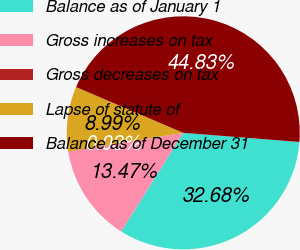<chart> <loc_0><loc_0><loc_500><loc_500><pie_chart><fcel>Balance as of January 1<fcel>Gross increases on tax<fcel>Gross decreases on tax<fcel>Lapse of statute of<fcel>Balance as of December 31<nl><fcel>32.68%<fcel>13.47%<fcel>0.03%<fcel>8.99%<fcel>44.83%<nl></chart> 